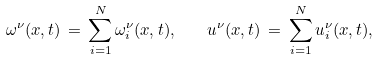Convert formula to latex. <formula><loc_0><loc_0><loc_500><loc_500>\omega ^ { \nu } ( x , t ) \, = \, \sum _ { i = 1 } ^ { N } \omega _ { i } ^ { \nu } ( x , t ) , \quad u ^ { \nu } ( x , t ) \, = \, \sum _ { i = 1 } ^ { N } u _ { i } ^ { \nu } ( x , t ) ,</formula> 